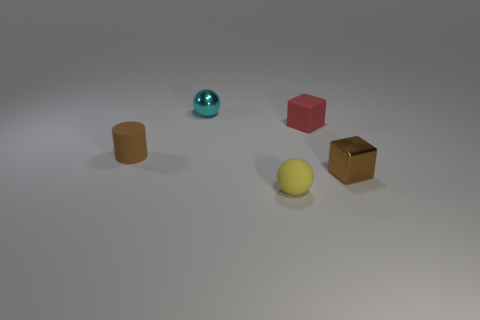Does the small yellow thing have the same shape as the cyan thing?
Make the answer very short. Yes. There is a shiny thing that is in front of the tiny brown thing on the left side of the tiny cyan metallic object; what number of small yellow rubber things are on the left side of it?
Give a very brief answer. 1. There is a tiny object that is to the left of the yellow rubber sphere and right of the small rubber cylinder; what is its material?
Offer a very short reply. Metal. What is the color of the small object that is on the right side of the yellow ball and behind the shiny cube?
Offer a terse response. Red. Is there anything else that is the same color as the tiny cylinder?
Your answer should be very brief. Yes. There is a small cyan thing that is behind the metallic thing in front of the small brown thing that is left of the small yellow thing; what is its shape?
Offer a very short reply. Sphere. There is a rubber thing that is the same shape as the tiny cyan metal thing; what is its color?
Offer a terse response. Yellow. The tiny ball in front of the small thing behind the tiny matte block is what color?
Give a very brief answer. Yellow. There is another thing that is the same shape as the red object; what is its size?
Ensure brevity in your answer.  Small. How many tiny yellow objects have the same material as the brown cylinder?
Keep it short and to the point. 1. 